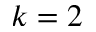Convert formula to latex. <formula><loc_0><loc_0><loc_500><loc_500>k = 2</formula> 